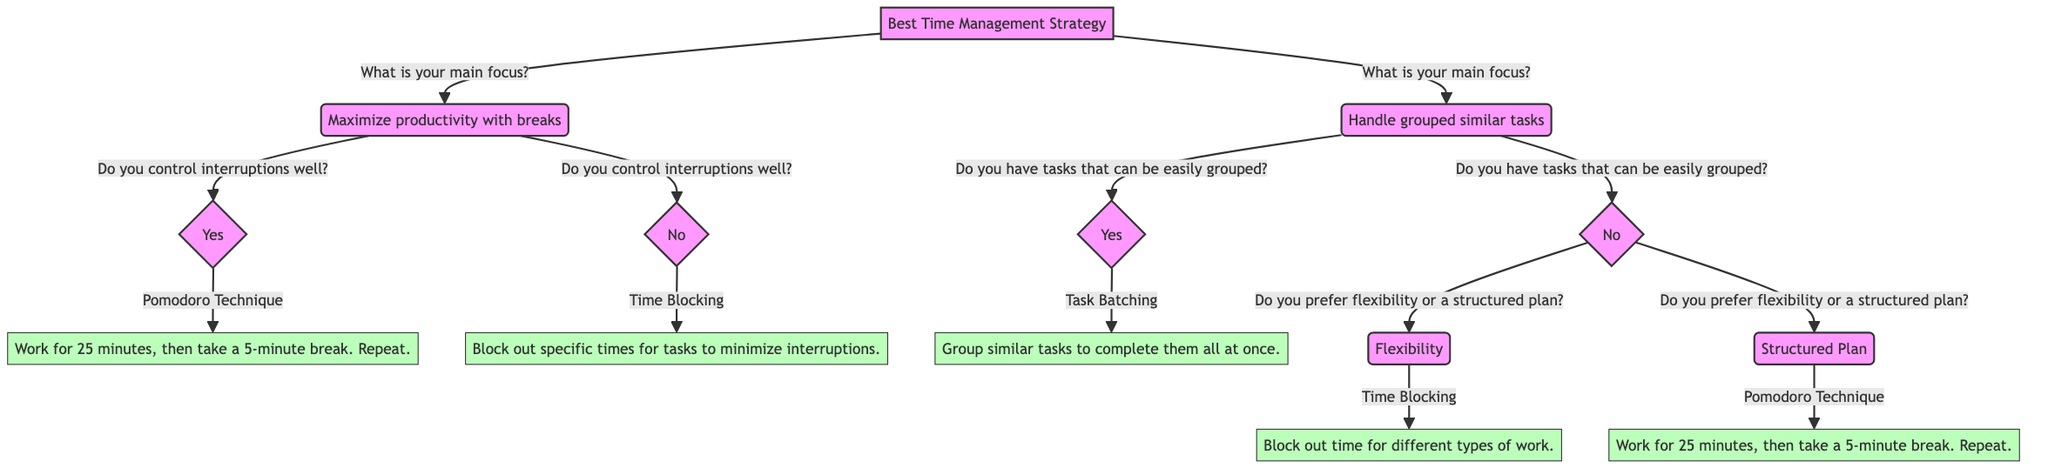What is the main focus for maximizing productivity with breaks? The first option under the decision node "Best Time Management Strategy" indicates that the main focus for this path is "Maximize productivity with breaks."
Answer: Maximize productivity with breaks How many total options exist after the initial question? The initial question "What is your main focus?" offers two options: "Maximize productivity with breaks" and "Handle grouped similar tasks," totaling two options.
Answer: 2 What strategy is suggested if you cannot control interruptions well? According to the diagram, if the answer to "Do you control interruptions well?" is "No," then the suggested strategy is "Time Blocking."
Answer: Time Blocking What is the strategy associated with grouping similar tasks? The option "Yes" under the question "Do you have tasks that can be easily grouped?" leads directly to the strategy "Task Batching."
Answer: Task Batching If you prefer flexibility, what is the recommended strategy? The "No" path under "Do you have tasks that can be easily grouped?" leads to the next question about preference, and if the answer is "Flexibility," the recommended strategy is "Time Blocking."
Answer: Time Blocking What is the description of the Pomodoro Technique? The strategy node "Pomodoro Technique" provides the description as "Work for 25 minutes, then take a 5-minute break. Repeat."
Answer: Work for 25 minutes, then take a 5-minute break. Repeat What happens if the answer to the question about grouping tasks is "No"? The path proceeds to ask "Do you prefer flexibility or a structured plan?" if the answer is "No," leading to two further options based on preference.
Answer: Do you prefer flexibility or a structured plan? Which strategy is suggested for a structured plan? If the answer to "Do you prefer flexibility or a structured plan?" is "Structured Plan," then the recommended strategy is "Pomodoro Technique."
Answer: Pomodoro Technique What indicates that a decision tree is being utilized? The structure with branches that represent decision points and outcomes aligns with the characteristics of a decision tree, guiding the user based on responses.
Answer: Decision tree 